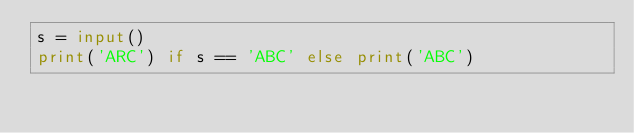Convert code to text. <code><loc_0><loc_0><loc_500><loc_500><_Python_>s = input()
print('ARC') if s == 'ABC' else print('ABC')</code> 